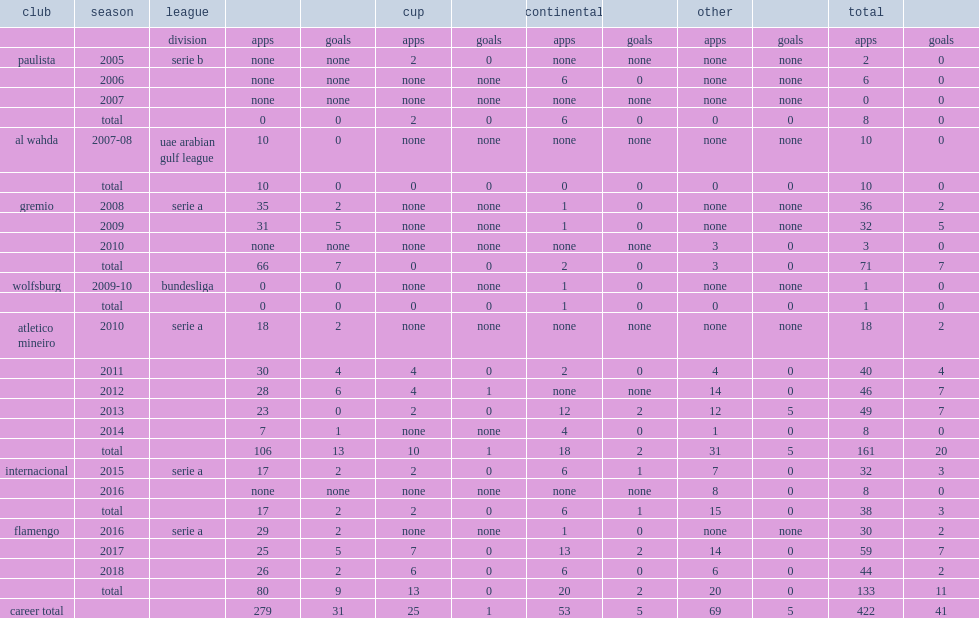Which club did rever play for in the 2010 serie a season? Atletico mineiro. 